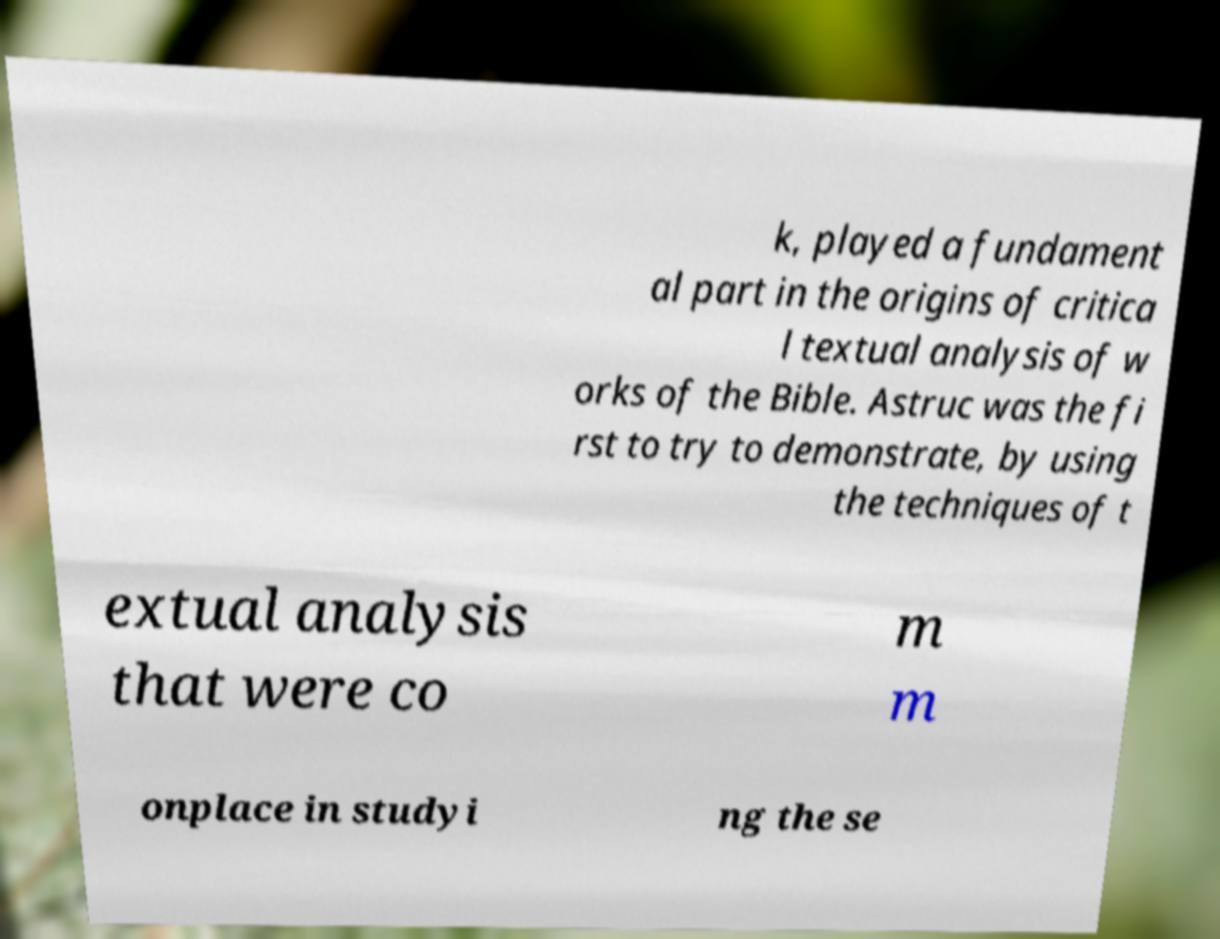Can you read and provide the text displayed in the image?This photo seems to have some interesting text. Can you extract and type it out for me? k, played a fundament al part in the origins of critica l textual analysis of w orks of the Bible. Astruc was the fi rst to try to demonstrate, by using the techniques of t extual analysis that were co m m onplace in studyi ng the se 